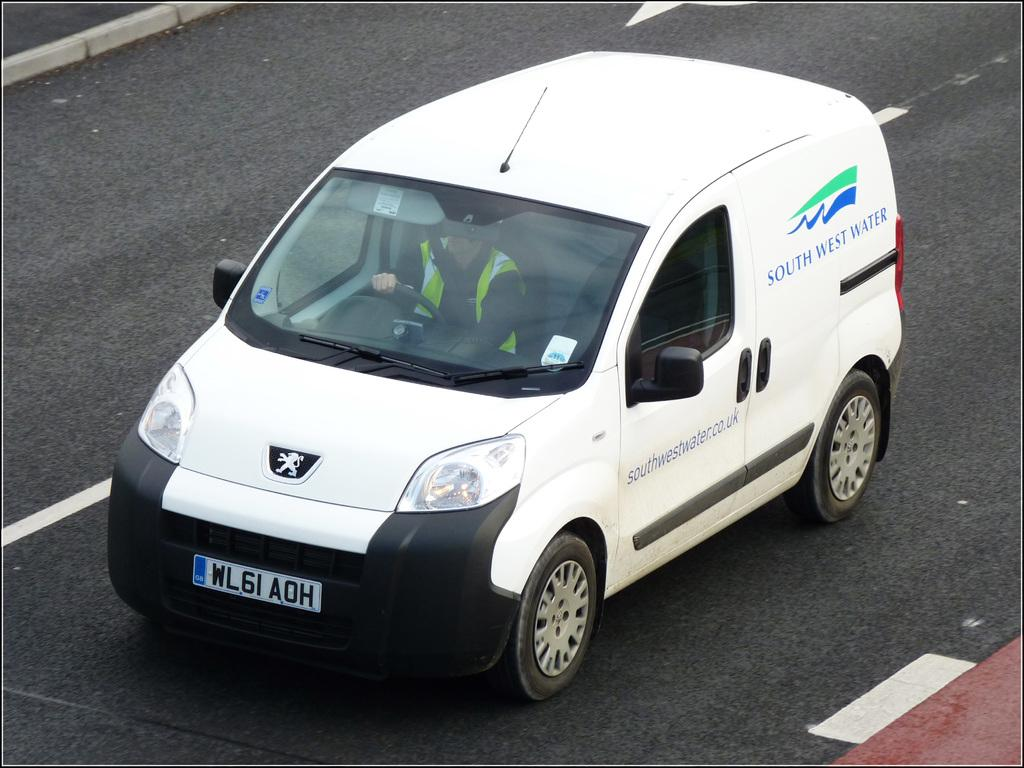<image>
Give a short and clear explanation of the subsequent image. A small white van with the words SOUTH WEST WATER on it. 